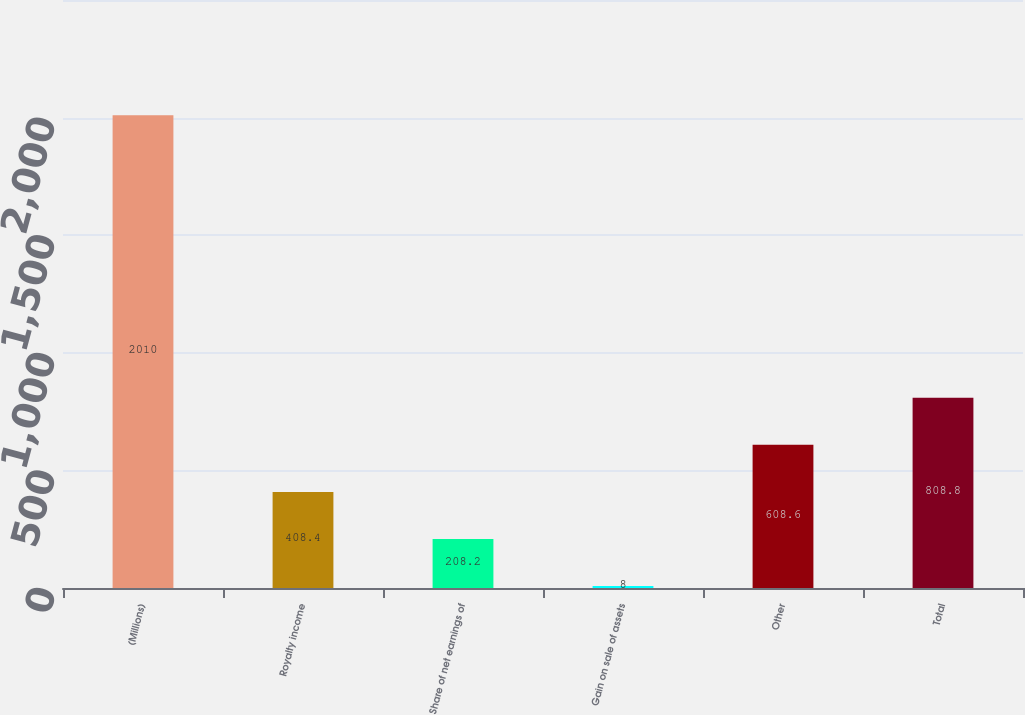<chart> <loc_0><loc_0><loc_500><loc_500><bar_chart><fcel>(Millions)<fcel>Royalty income<fcel>Share of net earnings of<fcel>Gain on sale of assets<fcel>Other<fcel>Total<nl><fcel>2010<fcel>408.4<fcel>208.2<fcel>8<fcel>608.6<fcel>808.8<nl></chart> 